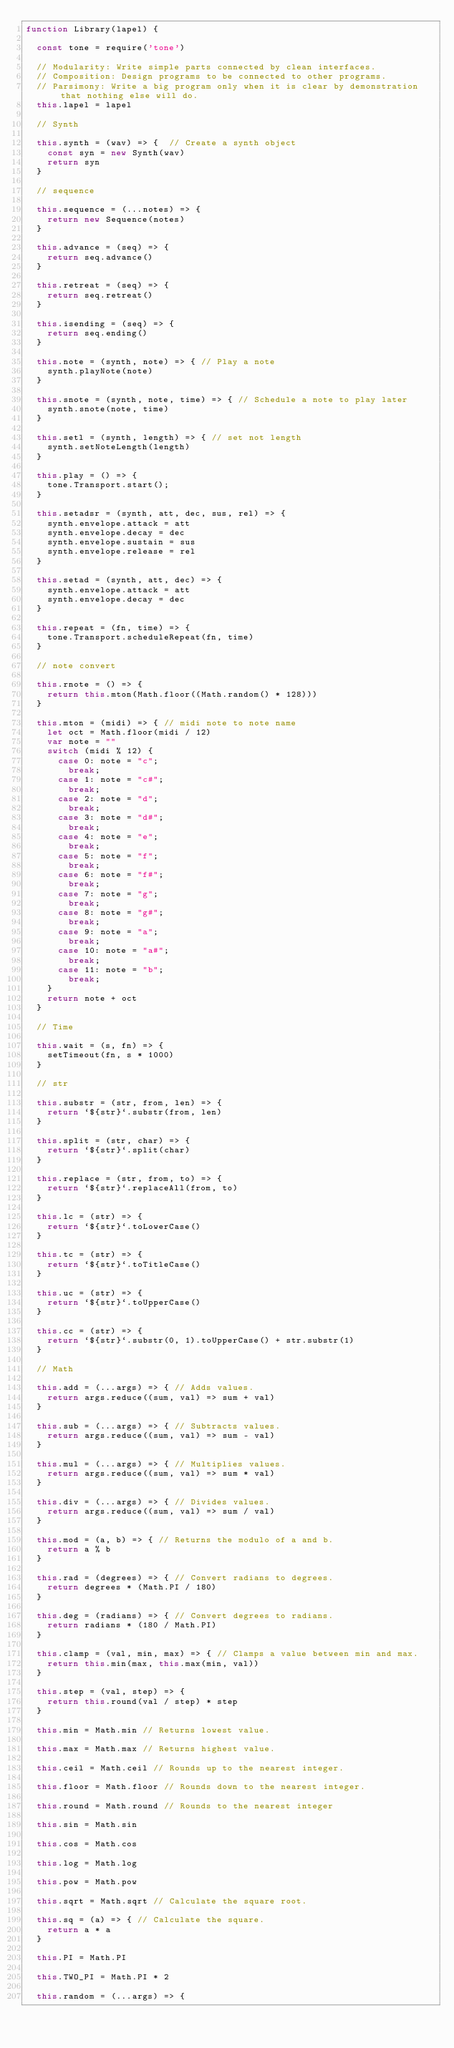Convert code to text. <code><loc_0><loc_0><loc_500><loc_500><_JavaScript_>function Library(lapel) {

  const tone = require('tone')

  // Modularity: Write simple parts connected by clean interfaces.
  // Composition: Design programs to be connected to other programs.
  // Parsimony: Write a big program only when it is clear by demonstration that nothing else will do.
  this.lapel = lapel

  // Synth

  this.synth = (wav) => {  // Create a synth object
    const syn = new Synth(wav)
    return syn
  }

  // sequence
  
  this.sequence = (...notes) => {
    return new Sequence(notes)
  }

  this.advance = (seq) => {
    return seq.advance()
  }

  this.retreat = (seq) => {
    return seq.retreat()
  }

  this.isending = (seq) => {
    return seq.ending()
  }

  this.note = (synth, note) => { // Play a note
    synth.playNote(note)
  }

  this.snote = (synth, note, time) => { // Schedule a note to play later
    synth.snote(note, time)
  }

  this.setl = (synth, length) => { // set not length
    synth.setNoteLength(length)
  }

  this.play = () => {
    tone.Transport.start();
  }

  this.setadsr = (synth, att, dec, sus, rel) => {
    synth.envelope.attack = att
    synth.envelope.decay = dec
    synth.envelope.sustain = sus
    synth.envelope.release = rel
  }

  this.setad = (synth, att, dec) => {
    synth.envelope.attack = att
    synth.envelope.decay = dec
  }

  this.repeat = (fn, time) => {
    tone.Transport.scheduleRepeat(fn, time)
  }

  // note convert

  this.rnote = () => {
    return this.mton(Math.floor((Math.random() * 128)))
  }

  this.mton = (midi) => { // midi note to note name
    let oct = Math.floor(midi / 12)
    var note = ""
    switch (midi % 12) {
      case 0: note = "c";
        break;
      case 1: note = "c#";
        break;
      case 2: note = "d";
        break;
      case 3: note = "d#";
        break;
      case 4: note = "e";
        break;
      case 5: note = "f";
        break;
      case 6: note = "f#";
        break;
      case 7: note = "g";
        break;
      case 8: note = "g#";
        break;
      case 9: note = "a";
        break;
      case 10: note = "a#";
        break;
      case 11: note = "b";
        break;
    }
    return note + oct
  }

  // Time

  this.wait = (s, fn) => {
    setTimeout(fn, s * 1000)
  }

  // str

  this.substr = (str, from, len) => {
    return `${str}`.substr(from, len)
  }

  this.split = (str, char) => {
    return `${str}`.split(char)
  }

  this.replace = (str, from, to) => {
    return `${str}`.replaceAll(from, to)
  }

  this.lc = (str) => {
    return `${str}`.toLowerCase()
  }

  this.tc = (str) => {
    return `${str}`.toTitleCase()
  }

  this.uc = (str) => {
    return `${str}`.toUpperCase()
  }

  this.cc = (str) => {
    return `${str}`.substr(0, 1).toUpperCase() + str.substr(1)
  }

  // Math

  this.add = (...args) => { // Adds values.
    return args.reduce((sum, val) => sum + val)
  }

  this.sub = (...args) => { // Subtracts values.
    return args.reduce((sum, val) => sum - val)
  }

  this.mul = (...args) => { // Multiplies values.
    return args.reduce((sum, val) => sum * val)
  }

  this.div = (...args) => { // Divides values.
    return args.reduce((sum, val) => sum / val)
  }

  this.mod = (a, b) => { // Returns the modulo of a and b.
    return a % b
  }

  this.rad = (degrees) => { // Convert radians to degrees.
    return degrees * (Math.PI / 180)
  }

  this.deg = (radians) => { // Convert degrees to radians.
    return radians * (180 / Math.PI)
  }

  this.clamp = (val, min, max) => { // Clamps a value between min and max.
    return this.min(max, this.max(min, val))
  }

  this.step = (val, step) => {
    return this.round(val / step) * step
  }

  this.min = Math.min // Returns lowest value.

  this.max = Math.max // Returns highest value.

  this.ceil = Math.ceil // Rounds up to the nearest integer.

  this.floor = Math.floor // Rounds down to the nearest integer.

  this.round = Math.round // Rounds to the nearest integer

  this.sin = Math.sin

  this.cos = Math.cos

  this.log = Math.log

  this.pow = Math.pow

  this.sqrt = Math.sqrt // Calculate the square root.

  this.sq = (a) => { // Calculate the square.
    return a * a
  }

  this.PI = Math.PI

  this.TWO_PI = Math.PI * 2

  this.random = (...args) => {</code> 